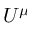<formula> <loc_0><loc_0><loc_500><loc_500>U ^ { \mu }</formula> 